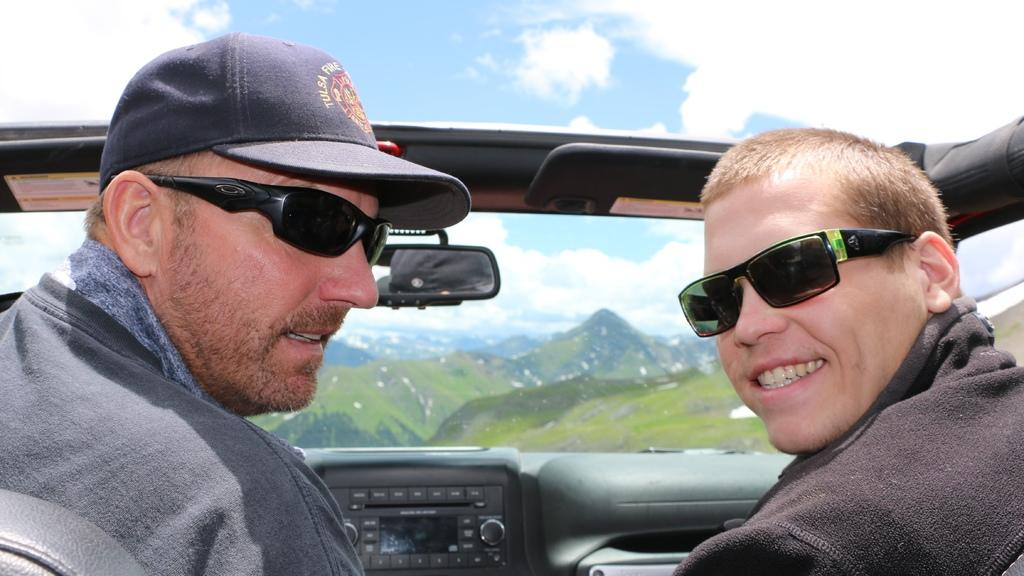How many people are in the image? There are two men in the image. What are the men doing in the image? The men are riding a car. What type of landscape can be seen in the image? There are mountains visible in the image. What is visible in the sky in the image? The sky is visible in the image, and clouds are present. How does the car measure the sense of snow in the image? The car does not measure the sense of snow in the image, as there is no mention of snow in the provided facts. 